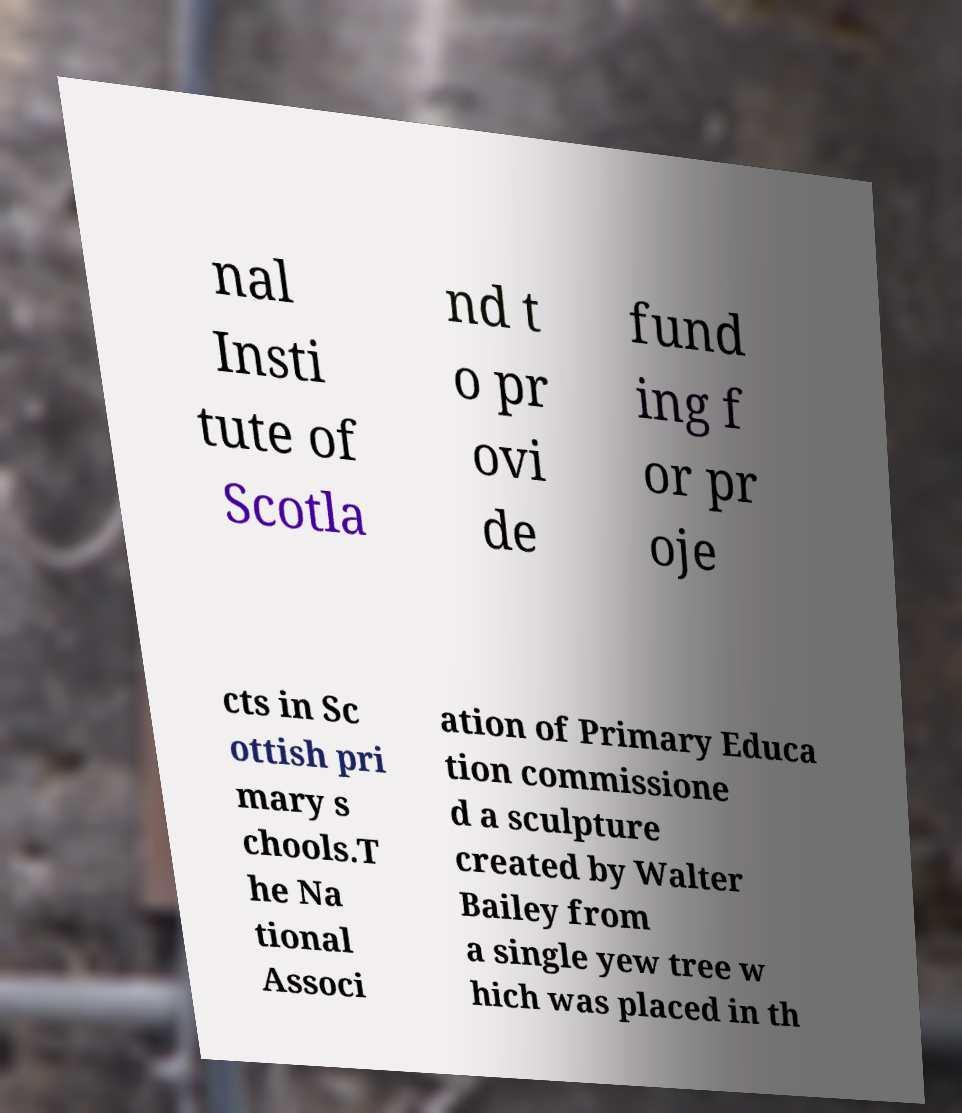Please identify and transcribe the text found in this image. nal Insti tute of Scotla nd t o pr ovi de fund ing f or pr oje cts in Sc ottish pri mary s chools.T he Na tional Associ ation of Primary Educa tion commissione d a sculpture created by Walter Bailey from a single yew tree w hich was placed in th 